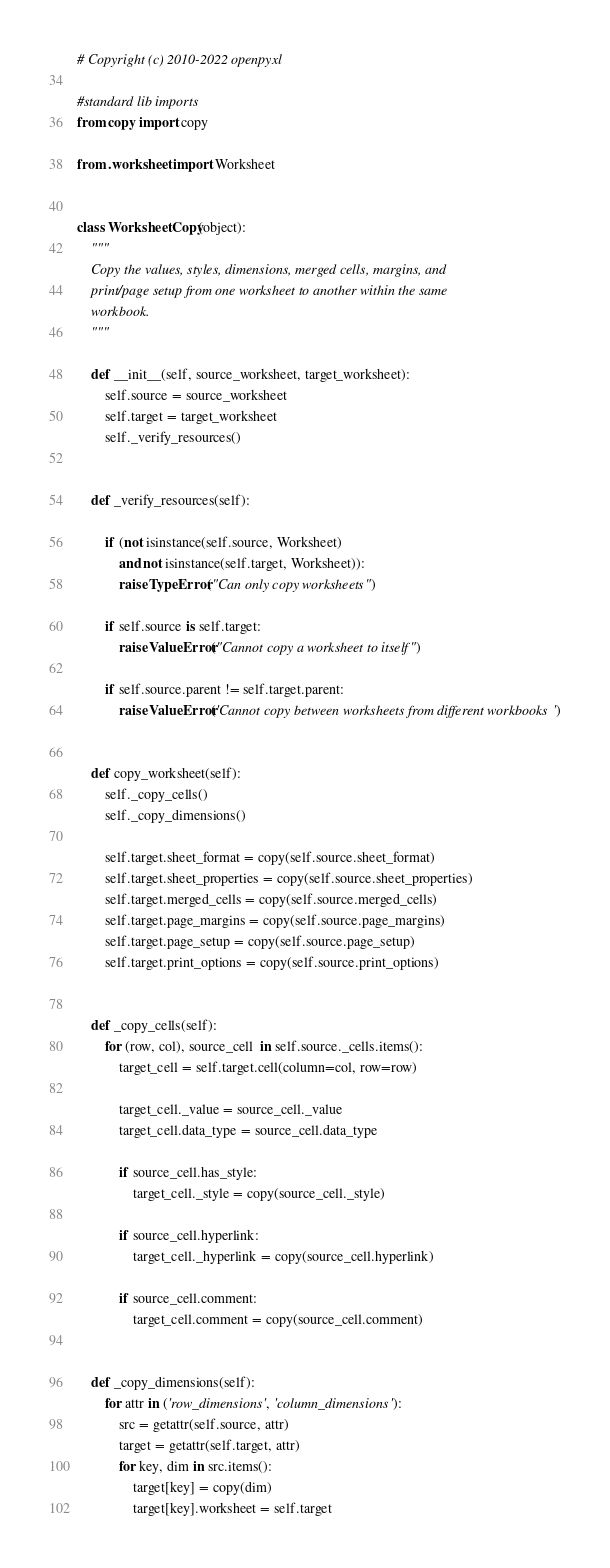Convert code to text. <code><loc_0><loc_0><loc_500><loc_500><_Python_># Copyright (c) 2010-2022 openpyxl

#standard lib imports
from copy import copy

from .worksheet import Worksheet


class WorksheetCopy(object):
    """
    Copy the values, styles, dimensions, merged cells, margins, and
    print/page setup from one worksheet to another within the same
    workbook.
    """

    def __init__(self, source_worksheet, target_worksheet):
        self.source = source_worksheet
        self.target = target_worksheet
        self._verify_resources()


    def _verify_resources(self):

        if (not isinstance(self.source, Worksheet)
            and not isinstance(self.target, Worksheet)):
            raise TypeError("Can only copy worksheets")

        if self.source is self.target:
            raise ValueError("Cannot copy a worksheet to itself")

        if self.source.parent != self.target.parent:
            raise ValueError('Cannot copy between worksheets from different workbooks')


    def copy_worksheet(self):
        self._copy_cells()
        self._copy_dimensions()

        self.target.sheet_format = copy(self.source.sheet_format)
        self.target.sheet_properties = copy(self.source.sheet_properties)
        self.target.merged_cells = copy(self.source.merged_cells)
        self.target.page_margins = copy(self.source.page_margins)
        self.target.page_setup = copy(self.source.page_setup)
        self.target.print_options = copy(self.source.print_options)


    def _copy_cells(self):
        for (row, col), source_cell  in self.source._cells.items():
            target_cell = self.target.cell(column=col, row=row)

            target_cell._value = source_cell._value
            target_cell.data_type = source_cell.data_type

            if source_cell.has_style:
                target_cell._style = copy(source_cell._style)

            if source_cell.hyperlink:
                target_cell._hyperlink = copy(source_cell.hyperlink)

            if source_cell.comment:
                target_cell.comment = copy(source_cell.comment)


    def _copy_dimensions(self):
        for attr in ('row_dimensions', 'column_dimensions'):
            src = getattr(self.source, attr)
            target = getattr(self.target, attr)
            for key, dim in src.items():
                target[key] = copy(dim)
                target[key].worksheet = self.target
</code> 